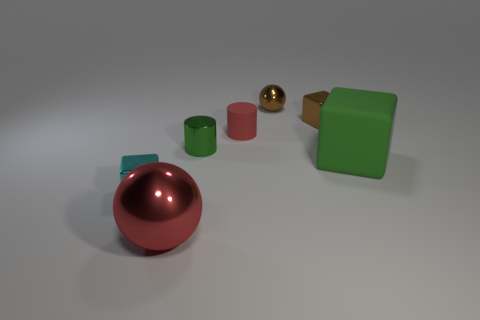Is there a metallic thing that is in front of the small red matte cylinder that is left of the shiny cube that is behind the small cyan thing?
Make the answer very short. Yes. What size is the metal sphere that is in front of the tiny cyan metallic object?
Provide a succinct answer. Large. What material is the red object that is the same size as the brown metallic ball?
Provide a succinct answer. Rubber. Do the green metallic object and the tiny red object have the same shape?
Ensure brevity in your answer.  Yes. How many things are small red rubber objects or balls behind the cyan shiny thing?
Your response must be concise. 2. There is a tiny cylinder that is the same color as the large shiny sphere; what material is it?
Offer a very short reply. Rubber. Do the red metal ball in front of the cyan shiny cube and the green matte thing have the same size?
Provide a short and direct response. Yes. There is a cylinder that is in front of the red object that is behind the big cube; what number of big spheres are to the right of it?
Your response must be concise. 0. What number of purple objects are either large metal spheres or big matte things?
Provide a succinct answer. 0. What is the color of the object that is the same material as the green cube?
Provide a short and direct response. Red. 